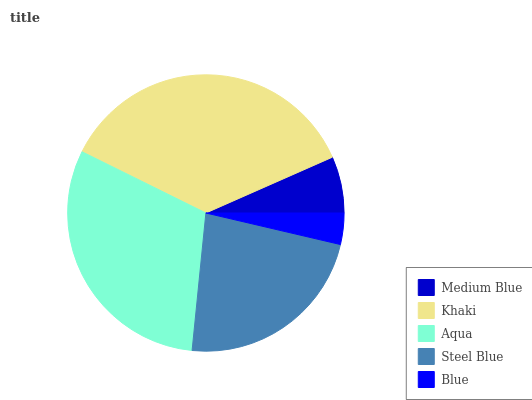Is Blue the minimum?
Answer yes or no. Yes. Is Khaki the maximum?
Answer yes or no. Yes. Is Aqua the minimum?
Answer yes or no. No. Is Aqua the maximum?
Answer yes or no. No. Is Khaki greater than Aqua?
Answer yes or no. Yes. Is Aqua less than Khaki?
Answer yes or no. Yes. Is Aqua greater than Khaki?
Answer yes or no. No. Is Khaki less than Aqua?
Answer yes or no. No. Is Steel Blue the high median?
Answer yes or no. Yes. Is Steel Blue the low median?
Answer yes or no. Yes. Is Medium Blue the high median?
Answer yes or no. No. Is Aqua the low median?
Answer yes or no. No. 